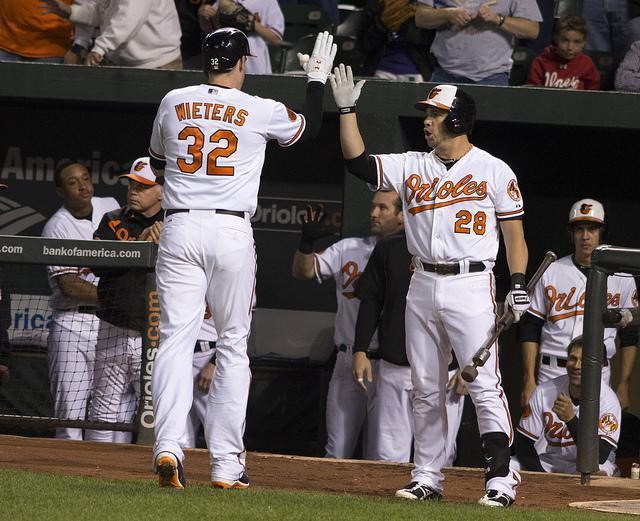How many people are in the picture?
Give a very brief answer. 13. 